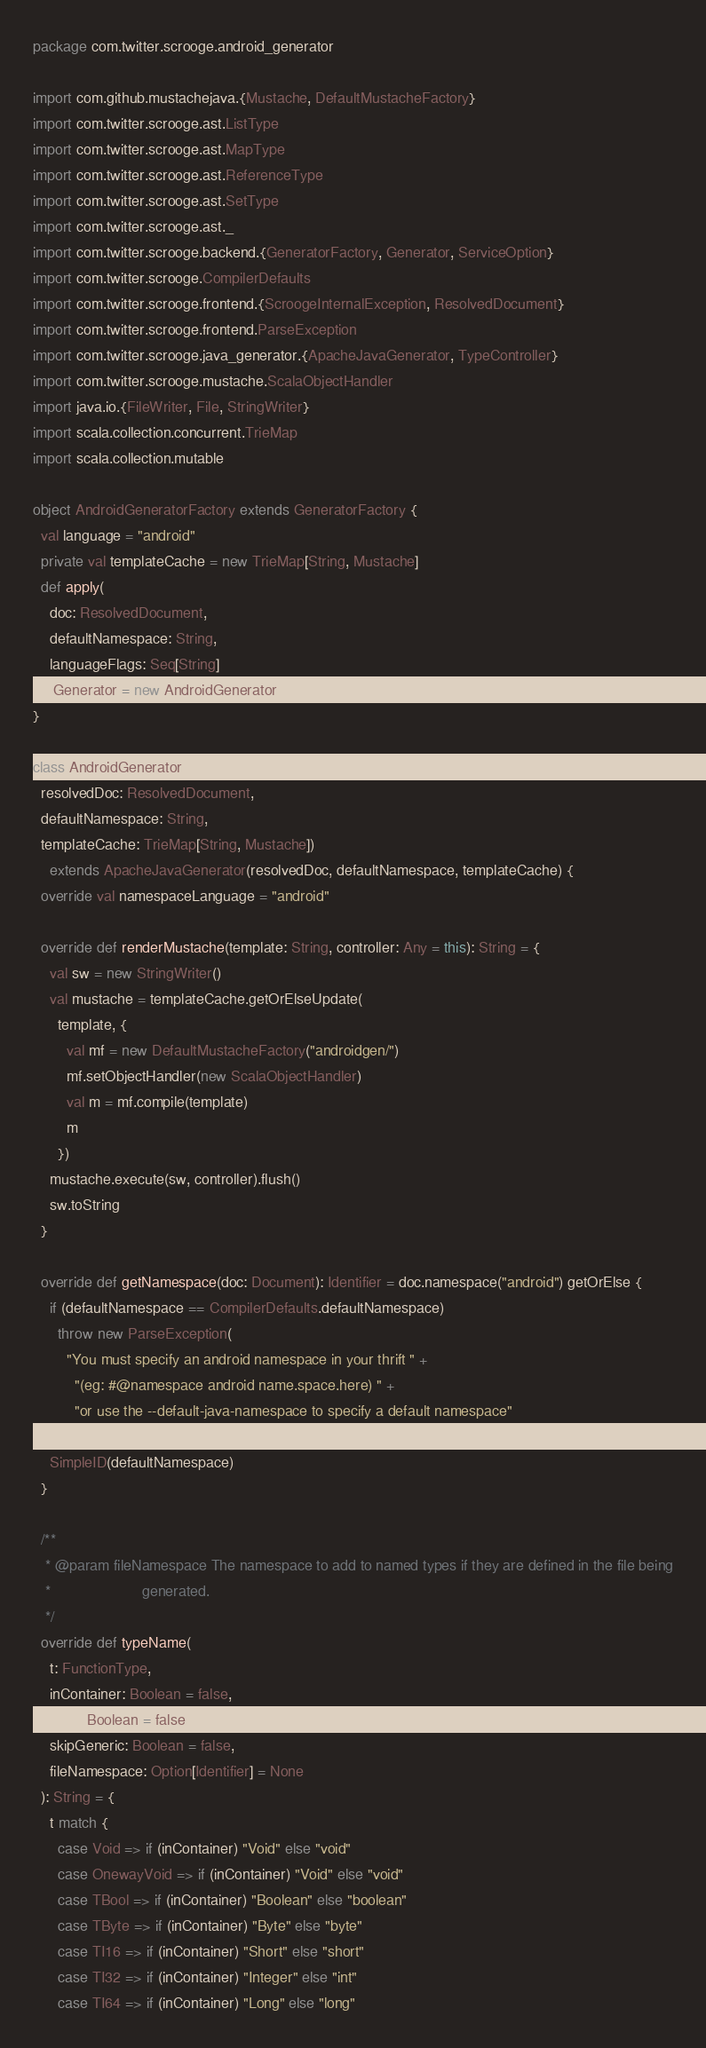<code> <loc_0><loc_0><loc_500><loc_500><_Scala_>package com.twitter.scrooge.android_generator

import com.github.mustachejava.{Mustache, DefaultMustacheFactory}
import com.twitter.scrooge.ast.ListType
import com.twitter.scrooge.ast.MapType
import com.twitter.scrooge.ast.ReferenceType
import com.twitter.scrooge.ast.SetType
import com.twitter.scrooge.ast._
import com.twitter.scrooge.backend.{GeneratorFactory, Generator, ServiceOption}
import com.twitter.scrooge.CompilerDefaults
import com.twitter.scrooge.frontend.{ScroogeInternalException, ResolvedDocument}
import com.twitter.scrooge.frontend.ParseException
import com.twitter.scrooge.java_generator.{ApacheJavaGenerator, TypeController}
import com.twitter.scrooge.mustache.ScalaObjectHandler
import java.io.{FileWriter, File, StringWriter}
import scala.collection.concurrent.TrieMap
import scala.collection.mutable

object AndroidGeneratorFactory extends GeneratorFactory {
  val language = "android"
  private val templateCache = new TrieMap[String, Mustache]
  def apply(
    doc: ResolvedDocument,
    defaultNamespace: String,
    languageFlags: Seq[String]
  ): Generator = new AndroidGenerator(doc, defaultNamespace, templateCache)
}

class AndroidGenerator(
  resolvedDoc: ResolvedDocument,
  defaultNamespace: String,
  templateCache: TrieMap[String, Mustache])
    extends ApacheJavaGenerator(resolvedDoc, defaultNamespace, templateCache) {
  override val namespaceLanguage = "android"

  override def renderMustache(template: String, controller: Any = this): String = {
    val sw = new StringWriter()
    val mustache = templateCache.getOrElseUpdate(
      template, {
        val mf = new DefaultMustacheFactory("androidgen/")
        mf.setObjectHandler(new ScalaObjectHandler)
        val m = mf.compile(template)
        m
      })
    mustache.execute(sw, controller).flush()
    sw.toString
  }

  override def getNamespace(doc: Document): Identifier = doc.namespace("android") getOrElse {
    if (defaultNamespace == CompilerDefaults.defaultNamespace)
      throw new ParseException(
        "You must specify an android namespace in your thrift " +
          "(eg: #@namespace android name.space.here) " +
          "or use the --default-java-namespace to specify a default namespace"
      )
    SimpleID(defaultNamespace)
  }

  /**
   * @param fileNamespace The namespace to add to named types if they are defined in the file being
   *                      generated.
   */
  override def typeName(
    t: FunctionType,
    inContainer: Boolean = false,
    inInit: Boolean = false,
    skipGeneric: Boolean = false,
    fileNamespace: Option[Identifier] = None
  ): String = {
    t match {
      case Void => if (inContainer) "Void" else "void"
      case OnewayVoid => if (inContainer) "Void" else "void"
      case TBool => if (inContainer) "Boolean" else "boolean"
      case TByte => if (inContainer) "Byte" else "byte"
      case TI16 => if (inContainer) "Short" else "short"
      case TI32 => if (inContainer) "Integer" else "int"
      case TI64 => if (inContainer) "Long" else "long"</code> 